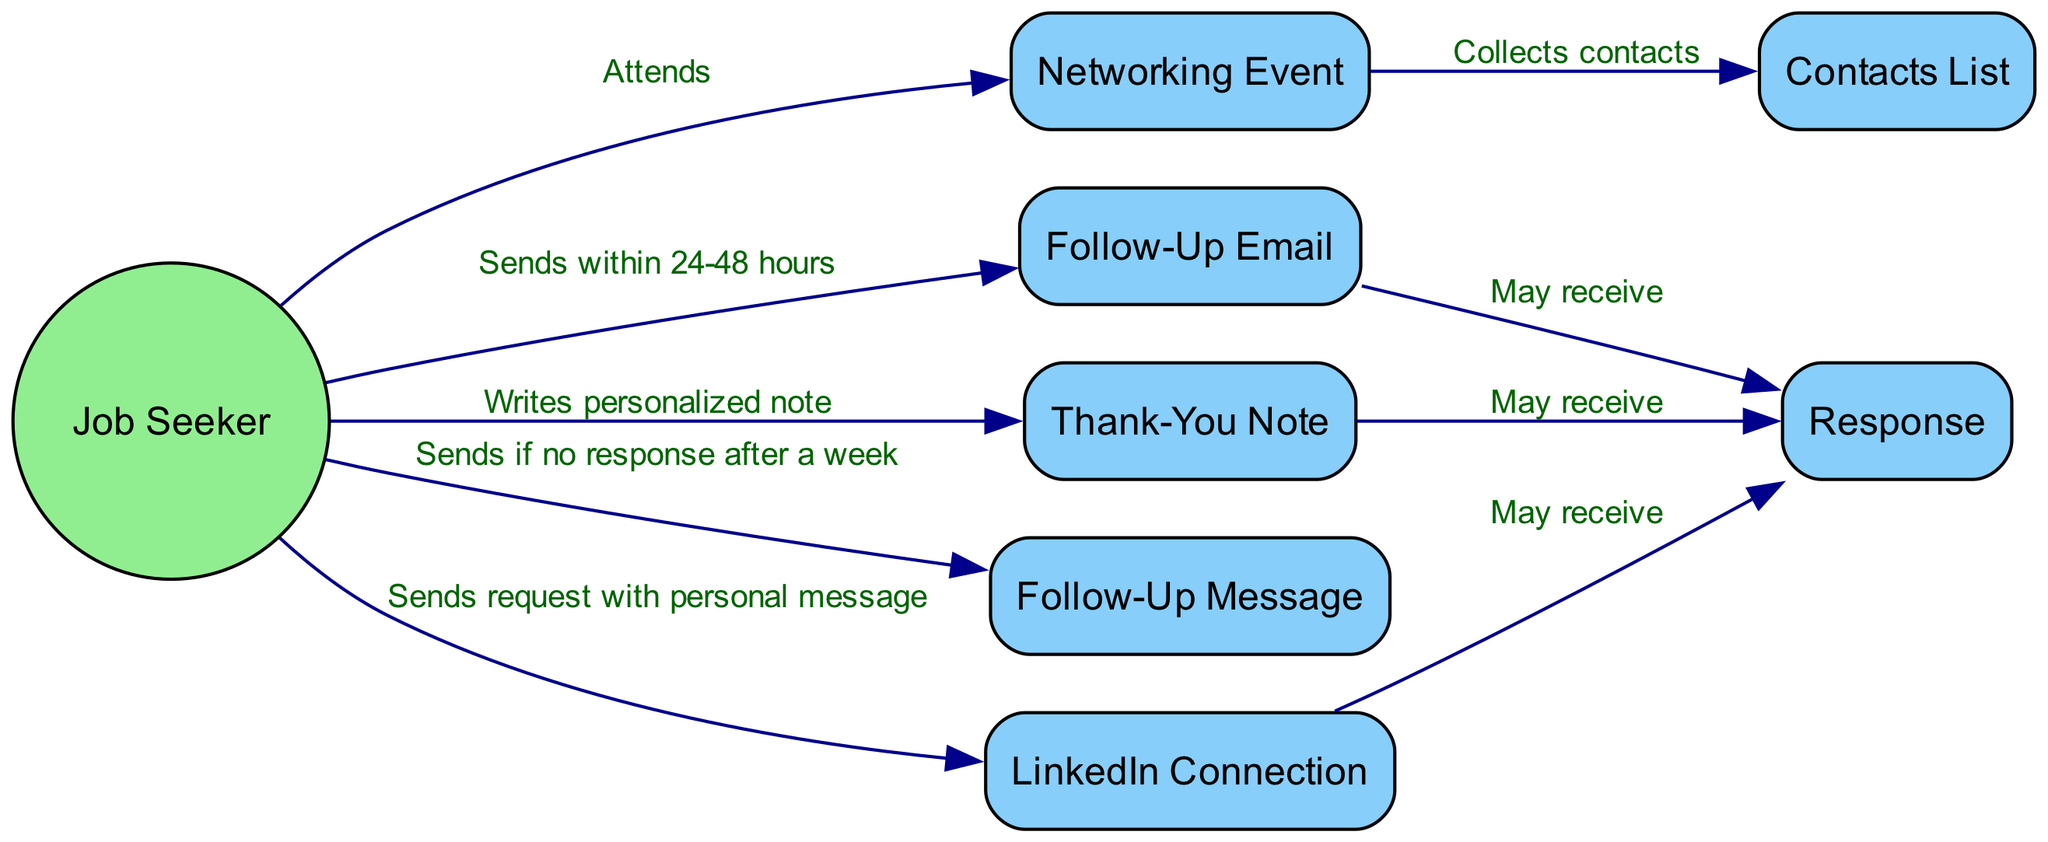What is the first action taken by the Job Seeker? The diagram shows that the first action the Job Seeker takes is attending the Networking Event, as indicated by the edge leading from the Job Seeker to the Networking Event labeled 'Attends'.
Answer: Attends How many objects are represented in the diagram? The diagram lists seven objects, which are the Networking Event, Contacts List, Follow-Up Email, Thank-You Note, Follow-Up Message, LinkedIn Connection, and Response. Counting these, we find there are seven objects in total.
Answer: Seven What does the Job Seeker do after collecting contacts? After collecting contacts from the Networking Event, the Job Seeker sends a Follow-Up Email, as indicated by the edge from Job Seeker to Follow-Up Email labeled 'Sends within 24-48 hours'.
Answer: Sends a Follow-Up Email What response might the Job Seeker receive after sending a Thank-You Note? The diagram indicates that the Job Seeker may receive a Response after sending the Thank-You Note, as shown by the edge connecting Thank-You Note to Response labeled 'May receive'.
Answer: May receive a Response What is the condition for sending a Follow-Up Message? The diagram specifies that the Job Seeker sends a Follow-Up Message if there is no response after a week, as indicated by the edge from Job Seeker to Follow-Up Message labeled 'Sends if no response after a week'.
Answer: If no response after a week What two actions has the Job Seeker taken to establish connections? The Job Seeker has taken two actions: sending a Follow-Up Email and sending a LinkedIn Connection request with a personal message. These actions are indicated by the respective edges from the Job Seeker to those objects in the diagram.
Answer: Sends a Follow-Up Email and LinkedIn Connection request How many different types of response can the Job Seeker receive? The diagram indicates that responses can be received from three different actions: Follow-Up Email, Thank-You Note, and LinkedIn Connection. Each of these actions connects to the Response object, implying there are multiple potential responses.
Answer: Three different responses What type of note does the Job Seeker write? The diagram indicates that the Job Seeker writes a Thank-You Note, as shown by the edge connecting Job Seeker to Thank-You Note labeled 'Writes personalized note'.
Answer: Thank-You Note Which action is taken last in the sequence? The last action taken in the sequence is the sending of a Follow-Up Message if there is no response after a week, which is depicted by the edge leading from Job Seeker to Follow-Up Message in the diagram.
Answer: Sending Follow-Up Message 